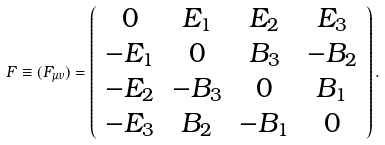Convert formula to latex. <formula><loc_0><loc_0><loc_500><loc_500>F \equiv ( F _ { \mu \nu } ) = \left ( \begin{array} { c c c c } { 0 } & { { E _ { 1 } } } & { { E _ { 2 } } } & { { E _ { 3 } } } \\ { { - E _ { 1 } } } & { 0 } & { { B _ { 3 } } } & { { - B _ { 2 } } } \\ { { - E _ { 2 } } } & { { - B _ { 3 } } } & { 0 } & { { B _ { 1 } } } \\ { { - E _ { 3 } } } & { { B _ { 2 } } } & { { - B _ { 1 } } } & { 0 } \end{array} \right ) .</formula> 